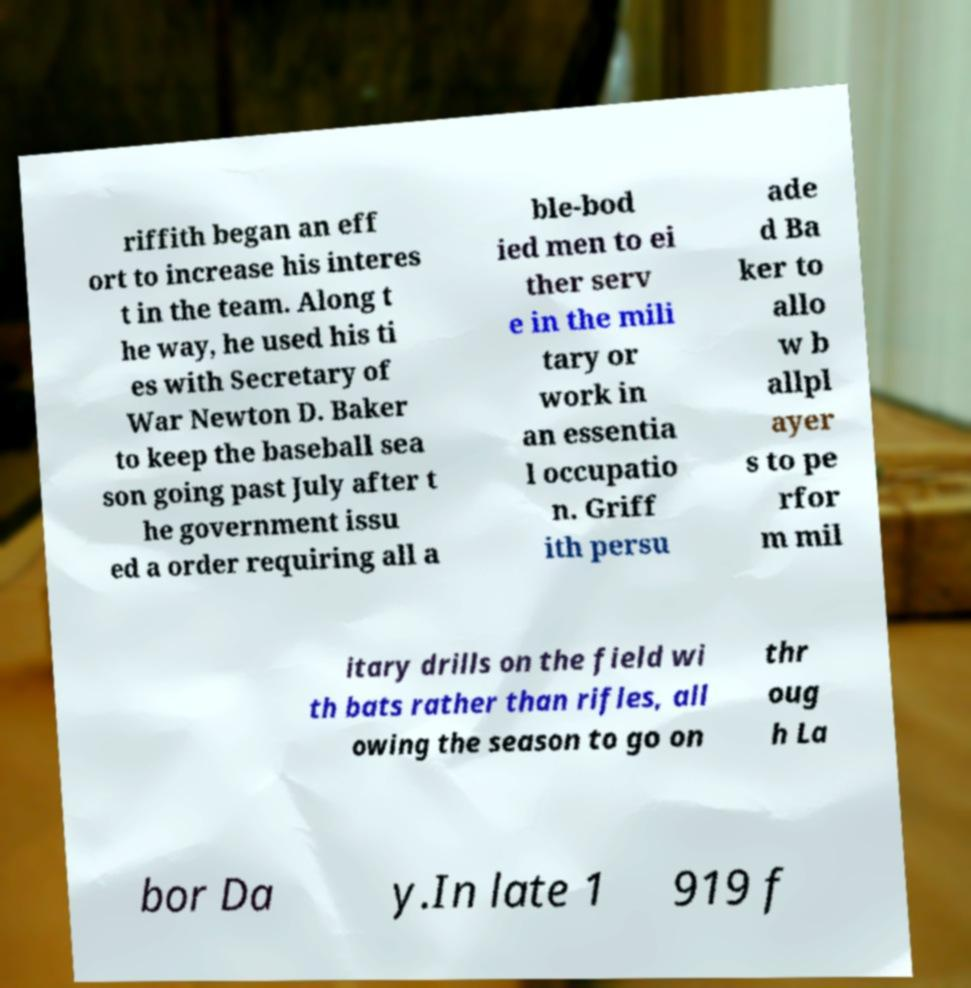For documentation purposes, I need the text within this image transcribed. Could you provide that? riffith began an eff ort to increase his interes t in the team. Along t he way, he used his ti es with Secretary of War Newton D. Baker to keep the baseball sea son going past July after t he government issu ed a order requiring all a ble-bod ied men to ei ther serv e in the mili tary or work in an essentia l occupatio n. Griff ith persu ade d Ba ker to allo w b allpl ayer s to pe rfor m mil itary drills on the field wi th bats rather than rifles, all owing the season to go on thr oug h La bor Da y.In late 1 919 f 